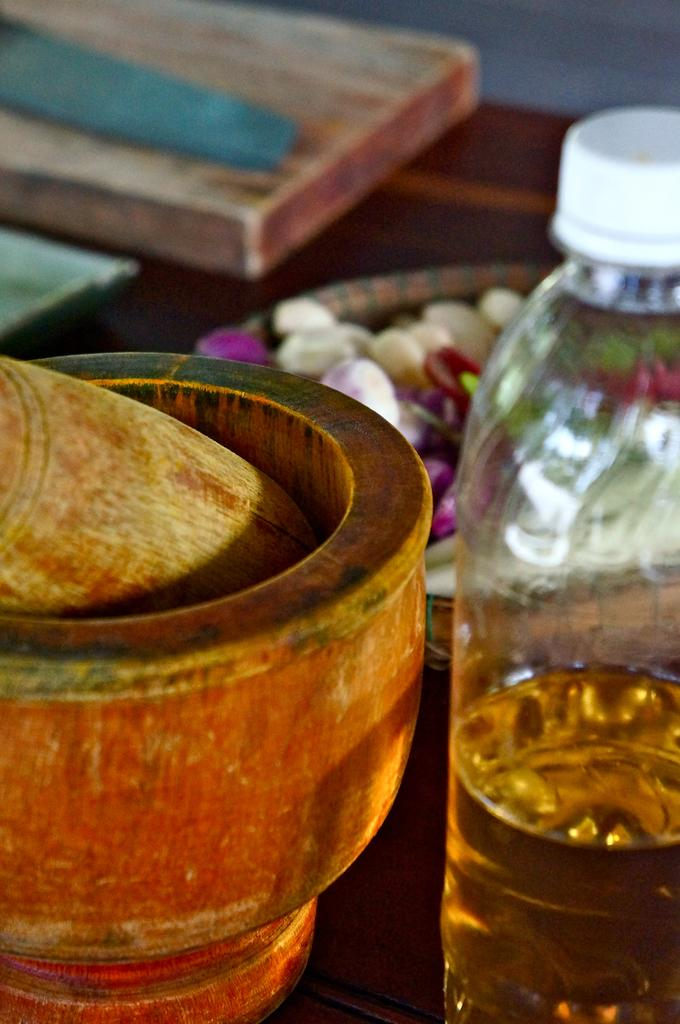What kitchen tool is present in the image? There is a mortar and pestle in the image. What type of liquid is contained in the bottle in the image? There is a bottle containing oil in the image. Can you describe any other items visible in the image? There are other unspecified items visible in the image. What type of books can be seen in the image? There are no books or a library present in the image. What kind of game is being played in the image? There is no game or game-related items present in the image. 